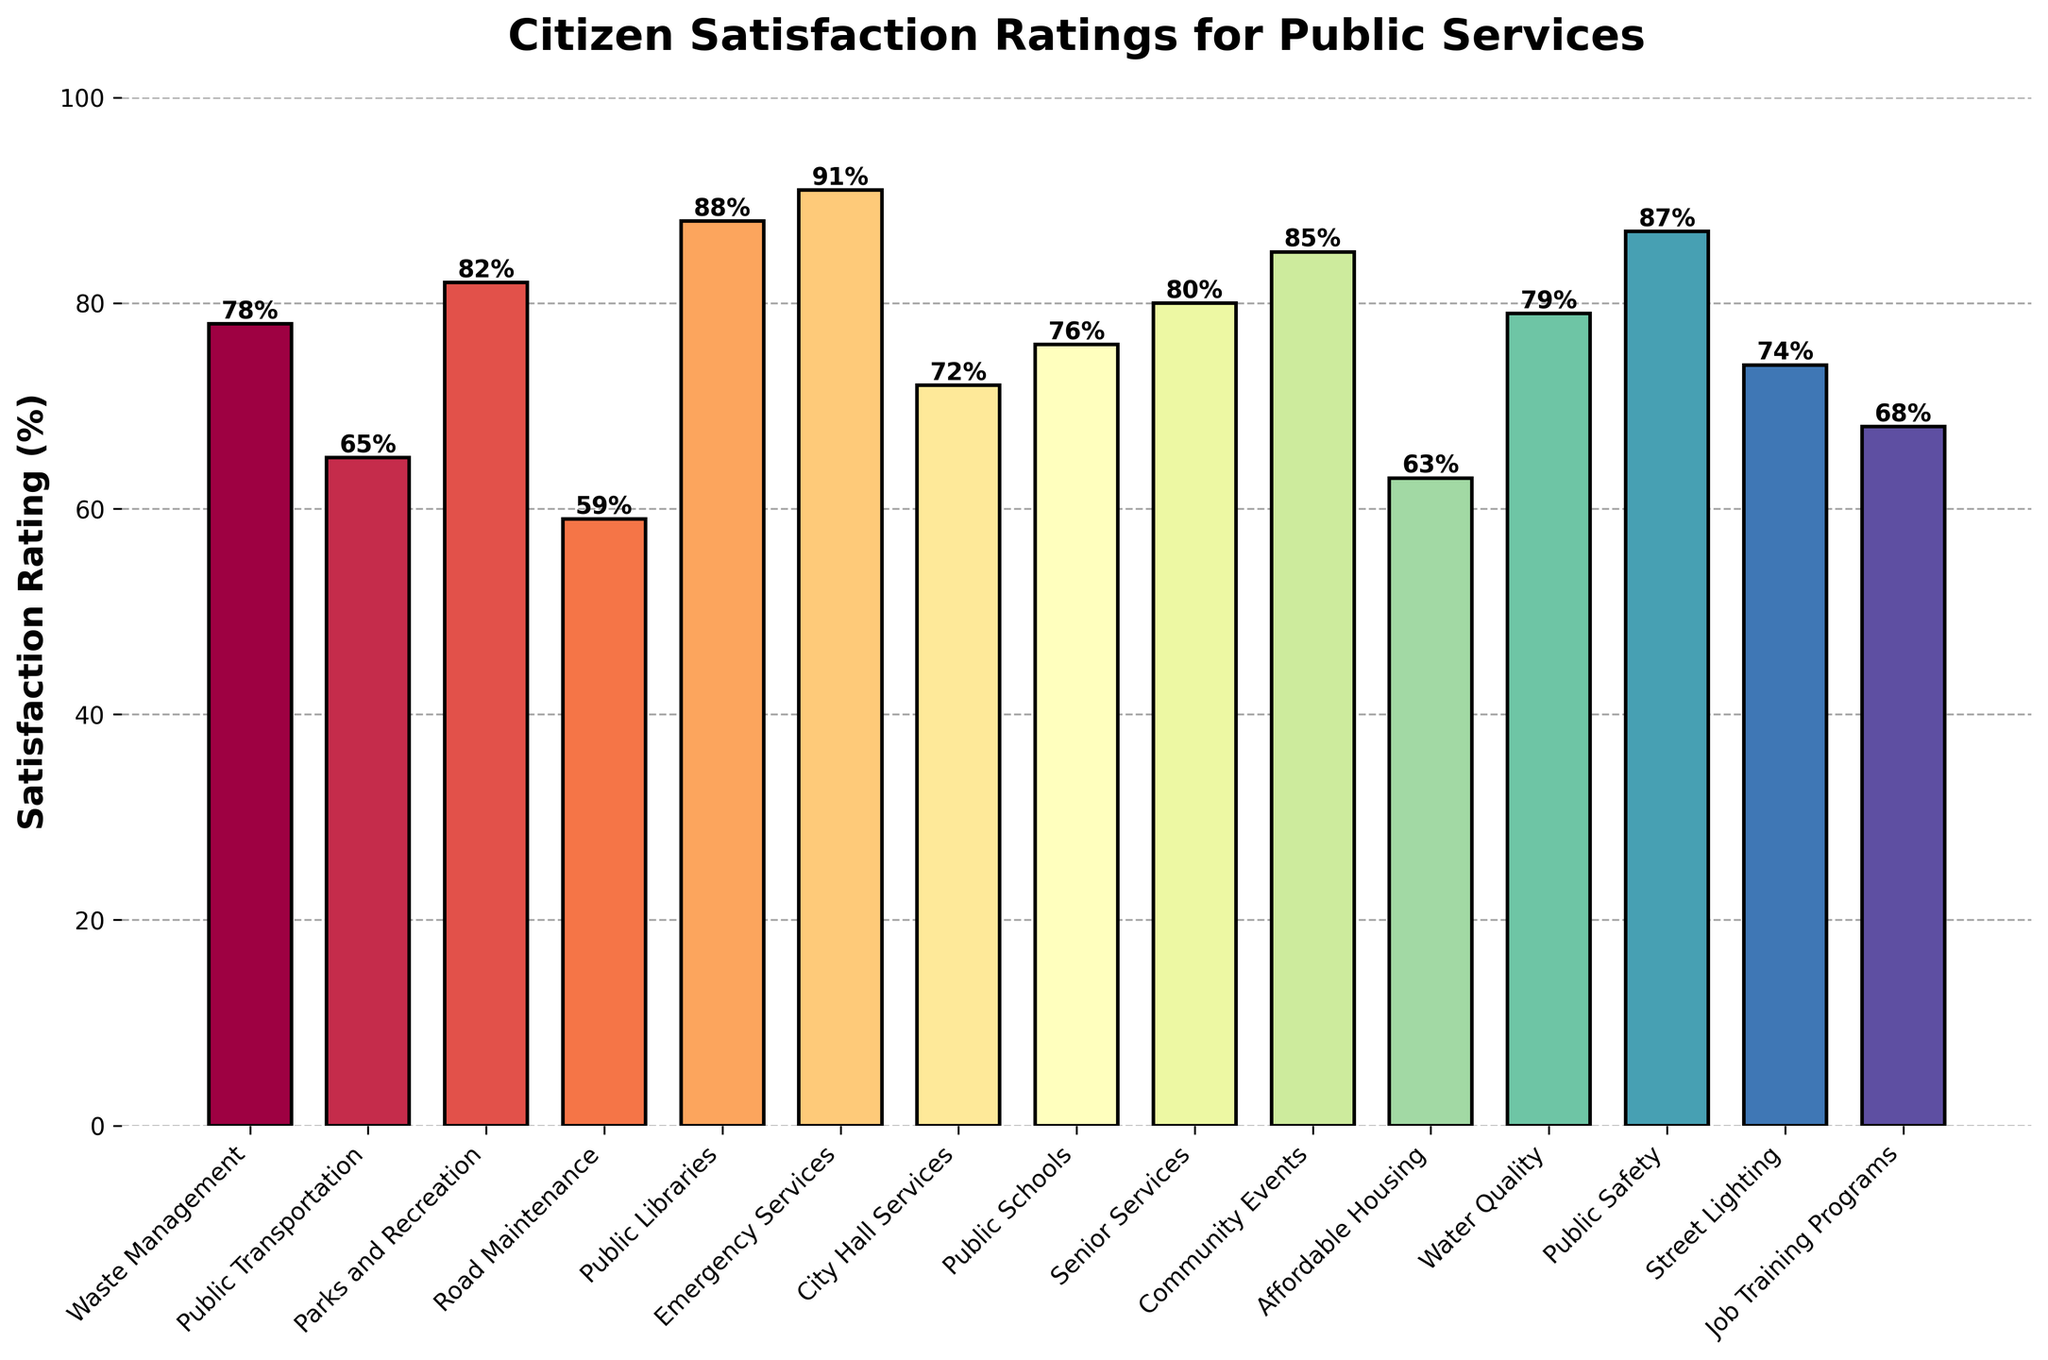Which service has the highest satisfaction rating? The highest bar represents the highest satisfaction rating. According to the figure, "Emergency Services" has the highest bar with a rating of 91.
Answer: Emergency Services How does the satisfaction rating for Affordable Housing compare to Public Safety? Compare the heights of the bars for Affordable Housing and Public Safety. Affordable Housing has a satisfaction rating of 63, while Public Safety has a rating of 87, making Public Safety's rating higher.
Answer: Public Safety is higher What is the combined satisfaction rating of Parks and Recreation, Public Libraries, and Community Events? Add the ratings of Parks and Recreation (82), Public Libraries (88), and Community Events (85). So the combined rating is 82 + 88 + 85 = 255.
Answer: 255 Which service has more satisfaction, Waste Management or Public Transportation? Compare the heights of the bars for Waste Management and Public Transportation. Waste Management has a satisfaction rating of 78 while Public Transportation has 65, so Waste Management has more satisfaction.
Answer: Waste Management What is the average satisfaction rating for Senior Services, Street Lighting, and Job Training Programs? Add the ratings of Senior Services (80), Street Lighting (74), and Job Training Programs (68) and then divide by 3. So, (80 + 74 + 68) / 3 = 222 / 3 = 74.
Answer: 74 Which service’s satisfaction rating is closest to 70? Look for bars with ratings close to 70. City Hall Services has a rating of 72, making it the closest to 70.
Answer: City Hall Services What’s the difference in satisfaction ratings between the highest and lowest rated services? Find the difference between the highest rating (Emergency Services, 91) and the lowest rating (Road Maintenance, 59). The difference is 91 - 59 = 32.
Answer: 32 Which services have a satisfaction rating above 80? Identify the bars with heights above 80. Parks and Recreation (82), Public Libraries (88), Emergency Services (91), Community Events (85), Public Safety (87) all have ratings above 80.
Answer: Parks and Recreation, Public Libraries, Emergency Services, Community Events, Public Safety Is the satisfaction rating of Water Quality greater than that of Street Lighting? Compare the heights of the bars for Water Quality and Street Lighting. Water Quality has a rating of 79, and Street Lighting has a rating of 74, making Water Quality's rating higher.
Answer: Yes How many services have a satisfaction rating between 60 and 80? Count the bars with ratings between 60 and 80. The services are Public Transportation (65), Affordable Housing (63), Public Schools (76), Waste Management (78), City Hall Services (72), Water Quality (79), Street Lighting (74), Job Training Programs (68), and Senior Services (80). There are 9 such services.
Answer: 9 